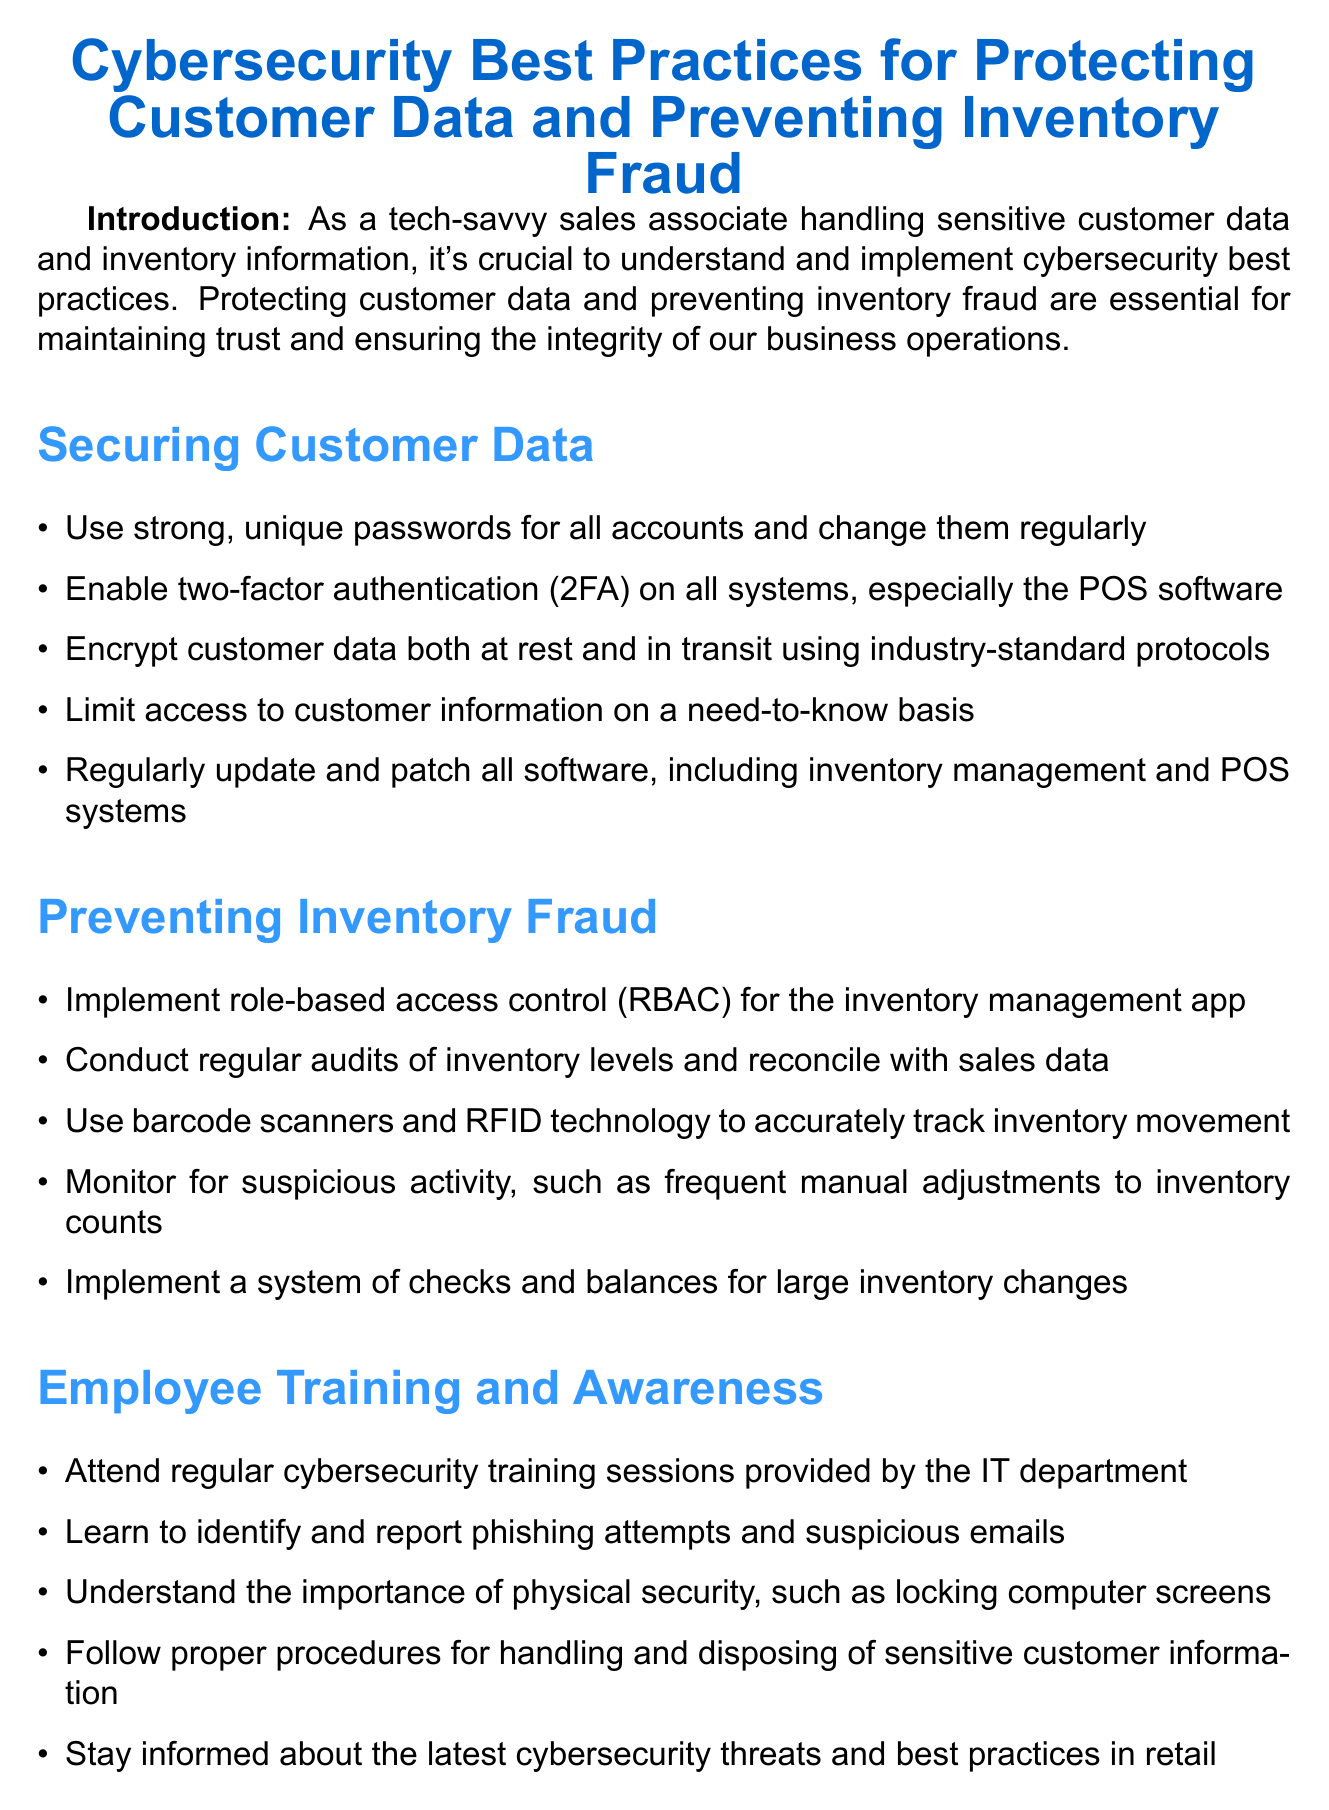What is the title of the memo? The title of the memo is presented at the start of the document and is essential for identifying its purpose.
Answer: Cybersecurity Best Practices for Protecting Customer Data and Preventing Inventory Fraud How many sections are there in the document? The document contains multiple sections that categorize information for clarity and organization.
Answer: Four What does 2FA stand for? This acronym is used in the section about securing customer data and is crucial for understanding cybersecurity measures.
Answer: Two-factor authentication What should be done if a device is lost? This detail is outlined in the best practices section and is important for safeguarding information.
Answer: Report it immediately to the IT department What technology is mentioned for tracking inventory movement? This information relates to the section on preventing inventory fraud and illustrates a method for improving accuracy.
Answer: Barcode scanners and RFID technology Which department provides regular cybersecurity training sessions? This point is highlighted in the employee training section to emphasize the importance of ongoing education about cybersecurity.
Answer: IT department What is the purpose of Microsoft Intune? Understanding the purpose of specific tools mentioned in the memo is vital to apply them correctly in workplace scenarios.
Answer: Mobile device management and application protection What should employees do if they encounter suspicious emails? This action is recommended in the employee training section and is crucial for recognizing potential threats.
Answer: Learn to identify and report phishing attempts How often should strong, unique passwords be changed? This specific requirement is stated in the securing customer data section and is a key practice for ensuring security.
Answer: Regularly 